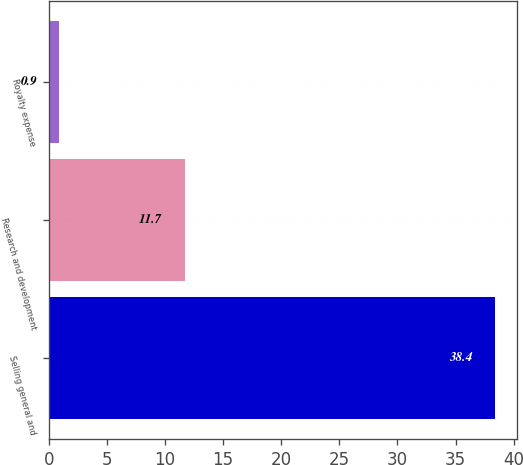<chart> <loc_0><loc_0><loc_500><loc_500><bar_chart><fcel>Selling general and<fcel>Research and development<fcel>Royalty expense<nl><fcel>38.4<fcel>11.7<fcel>0.9<nl></chart> 